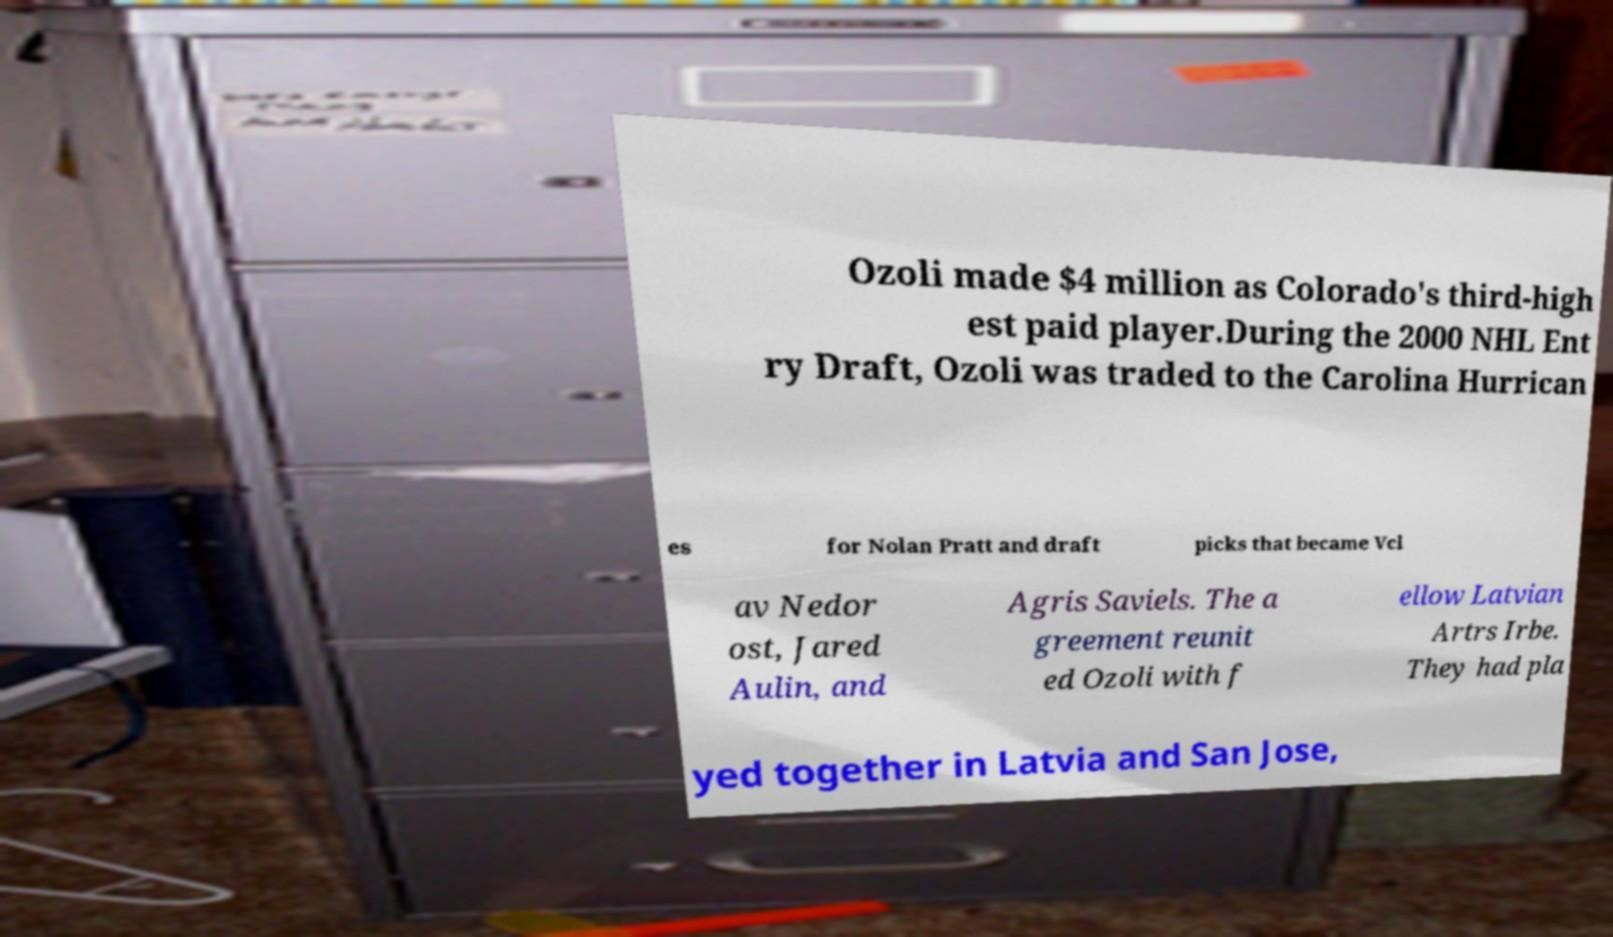There's text embedded in this image that I need extracted. Can you transcribe it verbatim? Ozoli made $4 million as Colorado's third-high est paid player.During the 2000 NHL Ent ry Draft, Ozoli was traded to the Carolina Hurrican es for Nolan Pratt and draft picks that became Vcl av Nedor ost, Jared Aulin, and Agris Saviels. The a greement reunit ed Ozoli with f ellow Latvian Artrs Irbe. They had pla yed together in Latvia and San Jose, 